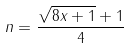<formula> <loc_0><loc_0><loc_500><loc_500>n = \frac { \sqrt { 8 x + 1 } + 1 } { 4 }</formula> 